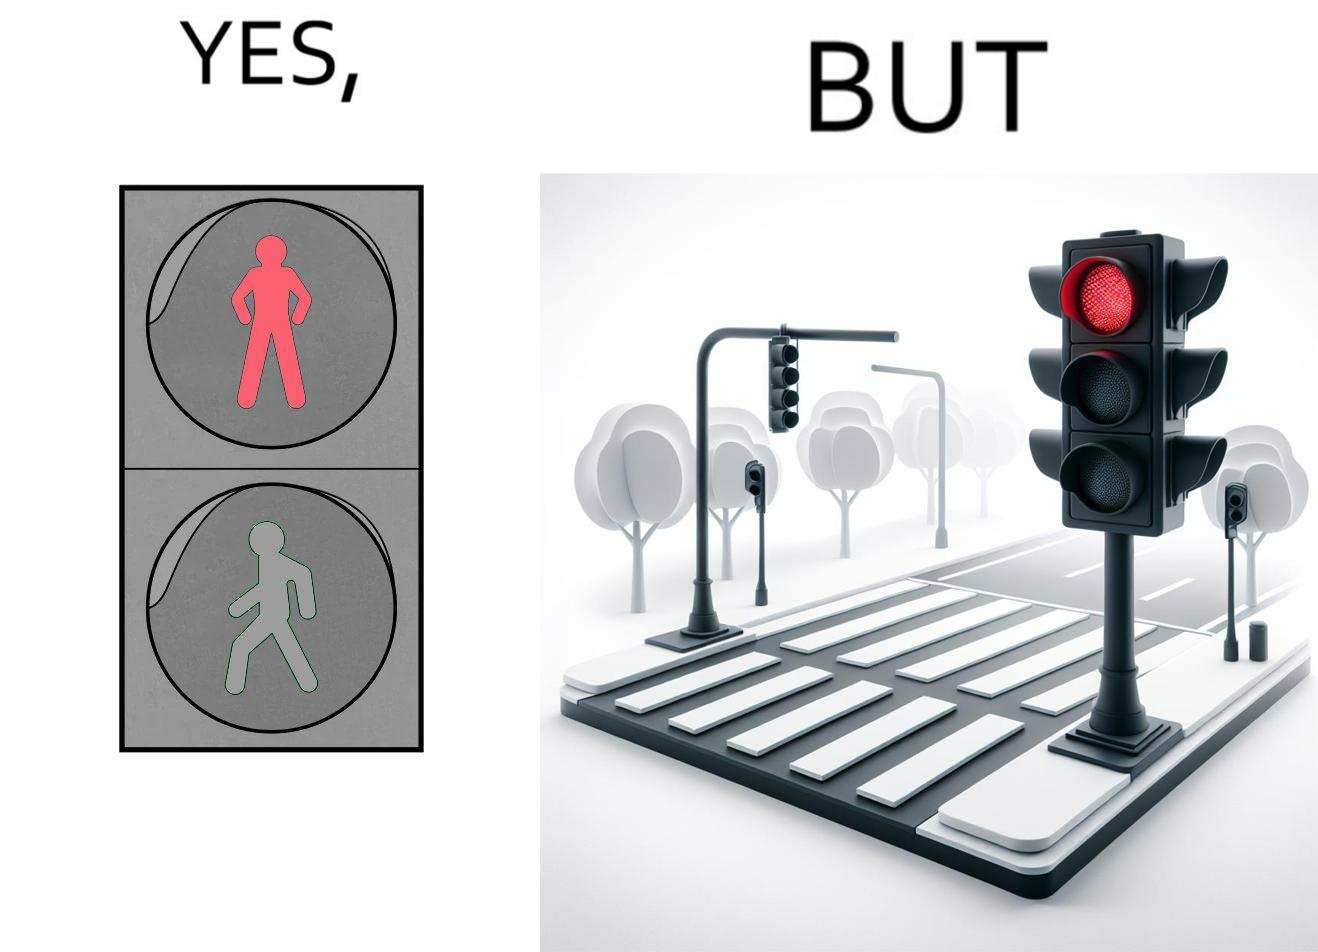Would you classify this image as satirical? Yes, this image is satirical. 